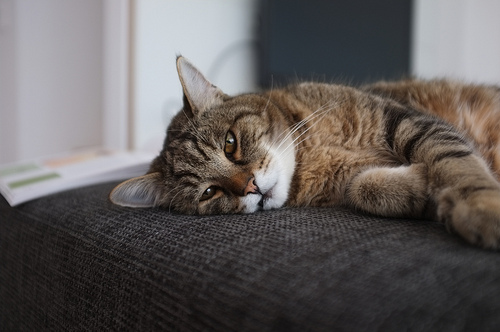<image>
Is the cat behind the chair? No. The cat is not behind the chair. From this viewpoint, the cat appears to be positioned elsewhere in the scene. 